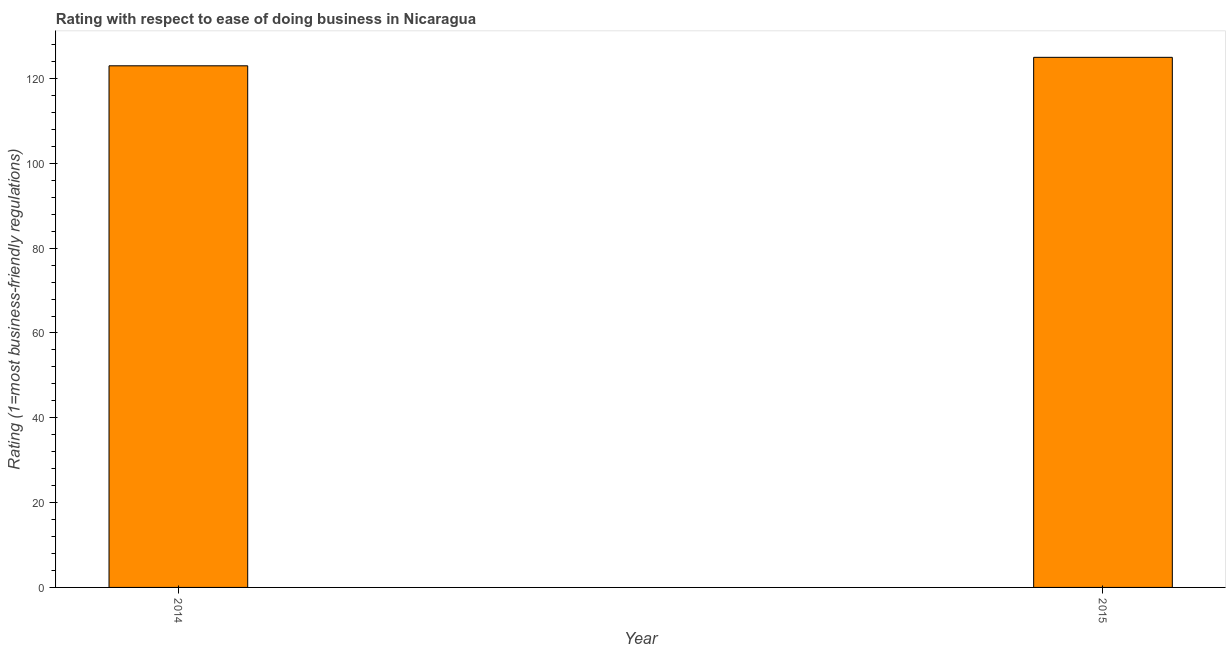Does the graph contain any zero values?
Ensure brevity in your answer.  No. What is the title of the graph?
Provide a short and direct response. Rating with respect to ease of doing business in Nicaragua. What is the label or title of the Y-axis?
Your answer should be compact. Rating (1=most business-friendly regulations). What is the ease of doing business index in 2014?
Offer a very short reply. 123. Across all years, what is the maximum ease of doing business index?
Offer a very short reply. 125. Across all years, what is the minimum ease of doing business index?
Keep it short and to the point. 123. In which year was the ease of doing business index maximum?
Give a very brief answer. 2015. What is the sum of the ease of doing business index?
Give a very brief answer. 248. What is the average ease of doing business index per year?
Your response must be concise. 124. What is the median ease of doing business index?
Keep it short and to the point. 124. What is the ratio of the ease of doing business index in 2014 to that in 2015?
Keep it short and to the point. 0.98. In how many years, is the ease of doing business index greater than the average ease of doing business index taken over all years?
Make the answer very short. 1. How many bars are there?
Give a very brief answer. 2. Are the values on the major ticks of Y-axis written in scientific E-notation?
Provide a succinct answer. No. What is the Rating (1=most business-friendly regulations) in 2014?
Provide a succinct answer. 123. What is the Rating (1=most business-friendly regulations) of 2015?
Your answer should be compact. 125. What is the difference between the Rating (1=most business-friendly regulations) in 2014 and 2015?
Offer a terse response. -2. What is the ratio of the Rating (1=most business-friendly regulations) in 2014 to that in 2015?
Make the answer very short. 0.98. 